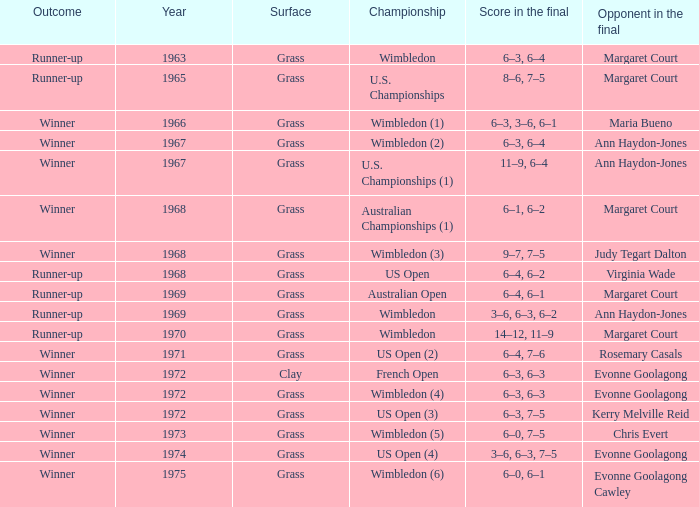What was the final score of the Australian Open? 6–4, 6–1. 